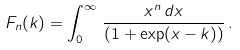Convert formula to latex. <formula><loc_0><loc_0><loc_500><loc_500>F _ { n } ( k ) = \int _ { 0 } ^ { \infty } \, \frac { x ^ { n } \, d x } { ( 1 + \exp ( x - k ) ) } \, .</formula> 